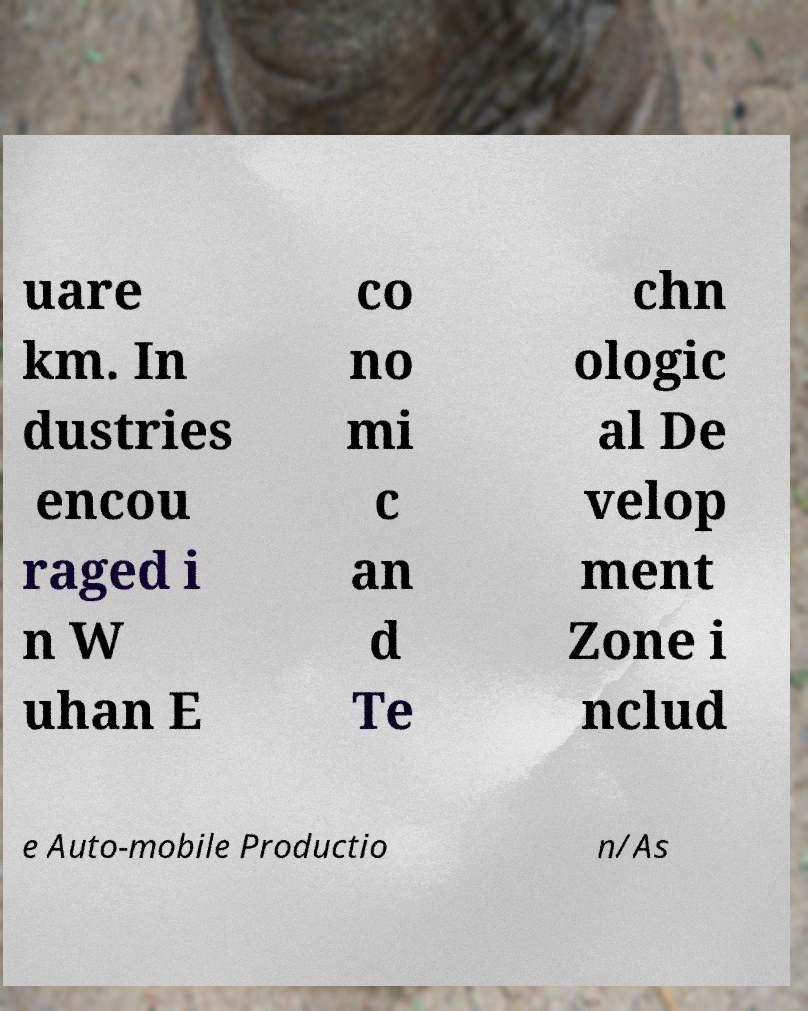For documentation purposes, I need the text within this image transcribed. Could you provide that? uare km. In dustries encou raged i n W uhan E co no mi c an d Te chn ologic al De velop ment Zone i nclud e Auto-mobile Productio n/As 